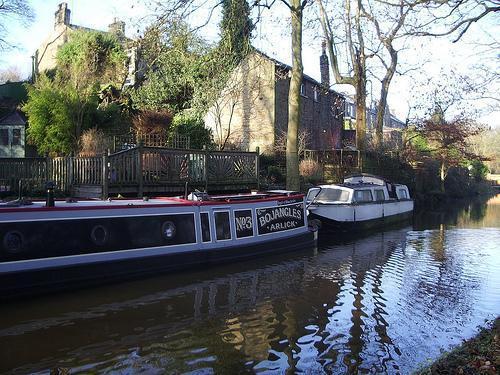How many boats are there?
Give a very brief answer. 2. How many canals are there?
Give a very brief answer. 1. 